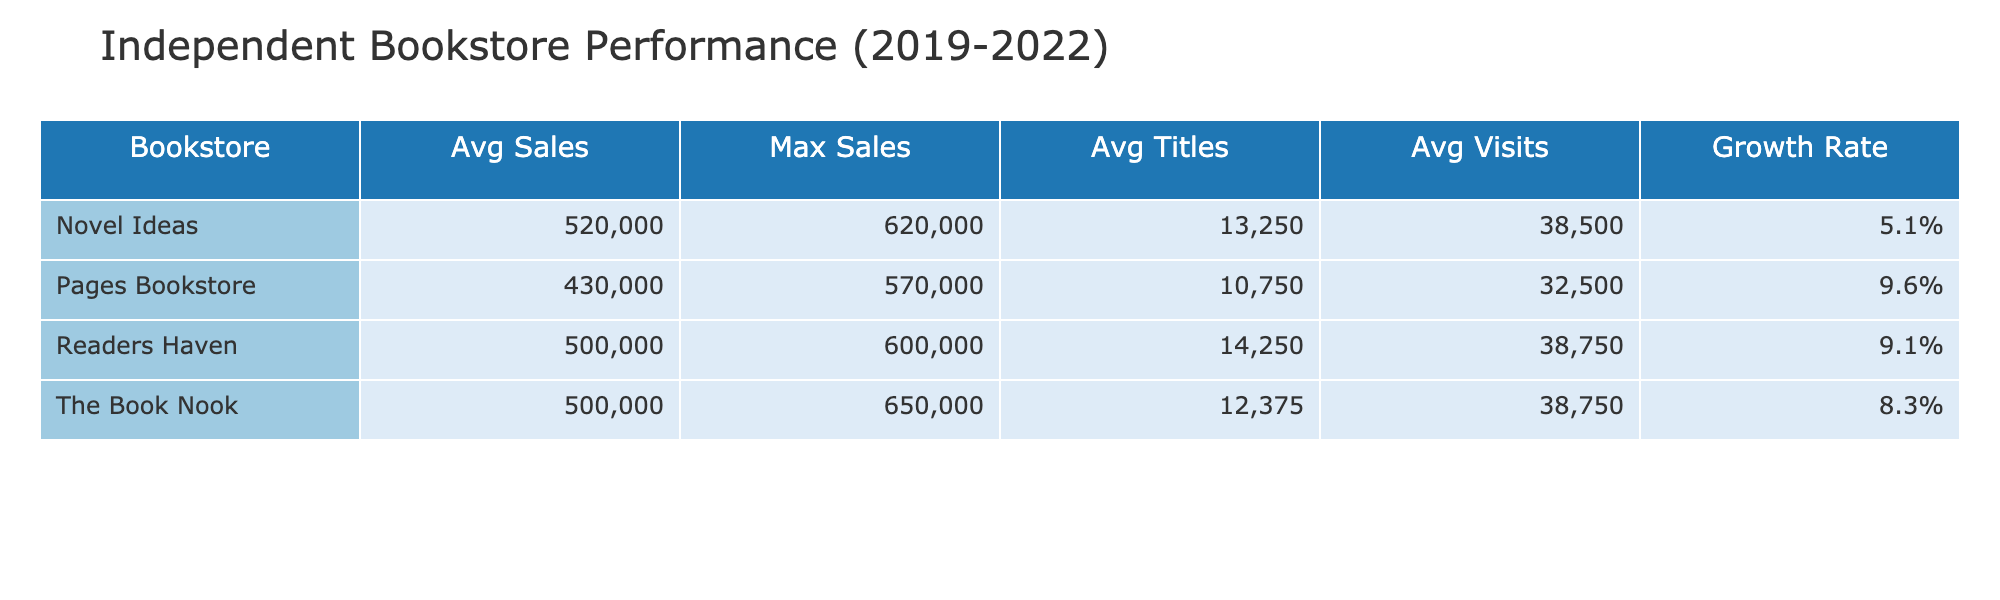What was the average sales for Readers Haven from 2019 to 2022? To find the average sales for Readers Haven, we add the total sales across the years: 500,000 (2019) + 350,000 (2020) + 550,000 (2021) + 600,000 (2022) = 2,000,000. We then divide by the 4 years to get the average: 2,000,000 / 4 = 500,000.
Answer: 500,000 Which bookstore had the highest maximum sales? Looking across the 'Max Sales' column in the table, we see that Novel Ideas had the highest maximum sales figure of 620,000 in 2022.
Answer: 620,000 Did The Book Nook experience a growth in sales from 2020 to 2021? By comparing The Book Nook’s sales in 2020 (300,000) and 2021 (600,000), we find sales increased from 300,000 to 600,000, indicating a growth.
Answer: Yes What is the average number of titles sold across all bookstores in 2022? We will sum the number of titles sold for each bookstore in 2022: 15,000 (The Book Nook) + 14,000 (Pages Bookstore) + 17,000 (Readers Haven) + 16,500 (Novel Ideas) = 62,500. Dividing by the 4 bookstores gives us 62,500 / 4 = 15,625.
Answer: 15,625 Which bookstore had the least number of customer visits in 2020? Checking the 'Customer Visits' column for the year 2020, Pages Bookstore had the least visits at 14,000.
Answer: 14,000 What was the overall trend in average sales from 2019 to 2022? Calculating the average sales for each year: For 2019, total sales = 2,000,000 divided by 4 bookstores = 500,000. For 2020, total = 1,300,000 divided by 4 = 325,000. For 2021, total = 2,260,000 divided by 4 = 565,000. For 2022, total = 2,510,000 divided by 4 = 627,500. The averages rise in sequence: 500,000, 325,000, 565,000, 627,500, indicating a positive trend.
Answer: Positive trend Is it true that Pages Bookstore's average sales are greater than those of The Book Nook? We need to compare their average sales: Pages Bookstore’s average is 525,000 and The Book Nook's average is 493,750, meaning Pages has a higher average.
Answer: Yes How much did Readers Haven's sales increase from 2019 to 2020? Readers Haven’s sales dropped from 500,000 (2019) to 350,000 (2020), a change of 350,000 - 500,000 = -150,000, indicating a decrease, not an increase.
Answer: Decrease of 150,000 